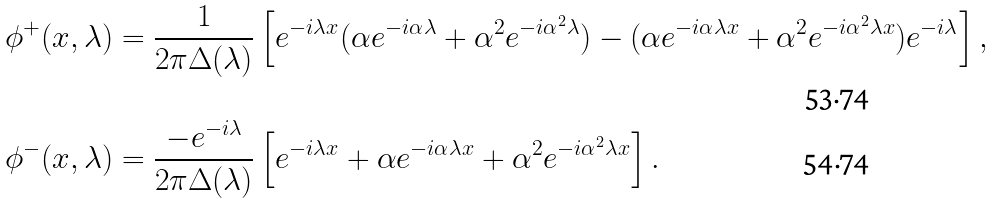<formula> <loc_0><loc_0><loc_500><loc_500>\phi ^ { + } ( x , \lambda ) & = \frac { 1 } { 2 \pi \Delta ( \lambda ) } \left [ e ^ { - i \lambda x } ( \alpha e ^ { - i \alpha \lambda } + \alpha ^ { 2 } e ^ { - i \alpha ^ { 2 } \lambda } ) - ( \alpha e ^ { - i \alpha \lambda x } + \alpha ^ { 2 } e ^ { - i \alpha ^ { 2 } \lambda x } ) e ^ { - i \lambda } \right ] , \\ \phi ^ { - } ( x , \lambda ) & = \frac { - e ^ { - i \lambda } } { 2 \pi \Delta ( \lambda ) } \left [ e ^ { - i \lambda x } + \alpha e ^ { - i \alpha \lambda x } + \alpha ^ { 2 } e ^ { - i \alpha ^ { 2 } \lambda x } \right ] .</formula> 